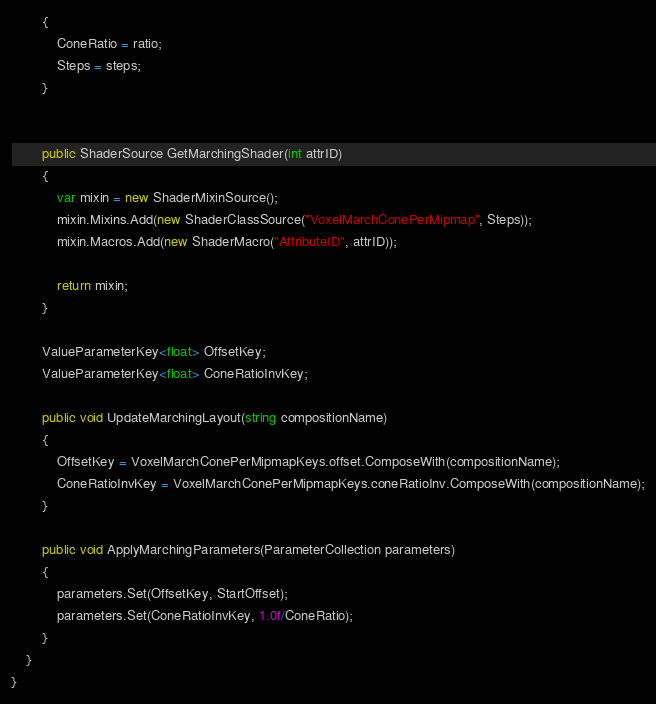Convert code to text. <code><loc_0><loc_0><loc_500><loc_500><_C#_>        {
            ConeRatio = ratio;
            Steps = steps;
        }


        public ShaderSource GetMarchingShader(int attrID)
        {
            var mixin = new ShaderMixinSource();
            mixin.Mixins.Add(new ShaderClassSource("VoxelMarchConePerMipmap", Steps));
            mixin.Macros.Add(new ShaderMacro("AttributeID", attrID));

            return mixin;
        }

        ValueParameterKey<float> OffsetKey;
        ValueParameterKey<float> ConeRatioInvKey;

        public void UpdateMarchingLayout(string compositionName)
        {
            OffsetKey = VoxelMarchConePerMipmapKeys.offset.ComposeWith(compositionName);
            ConeRatioInvKey = VoxelMarchConePerMipmapKeys.coneRatioInv.ComposeWith(compositionName);
        }

        public void ApplyMarchingParameters(ParameterCollection parameters)
        {
            parameters.Set(OffsetKey, StartOffset);
            parameters.Set(ConeRatioInvKey, 1.0f/ConeRatio);
        }
    }
}
</code> 